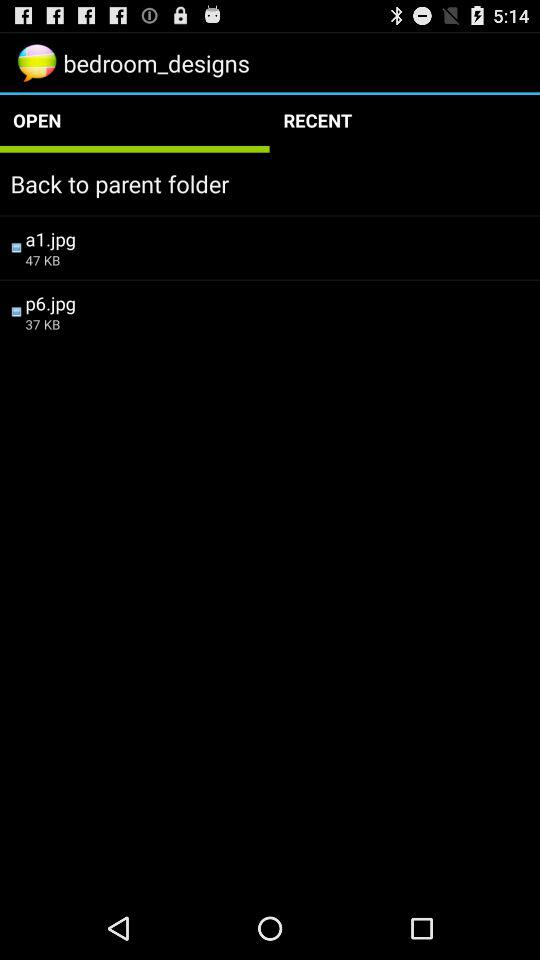How many items are in "RECENT"?
When the provided information is insufficient, respond with <no answer>. <no answer> 